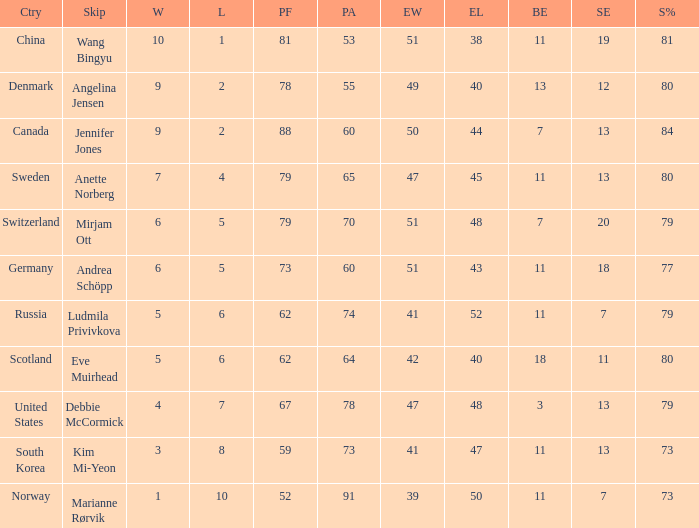What is Norway's least ends lost? 50.0. Help me parse the entirety of this table. {'header': ['Ctry', 'Skip', 'W', 'L', 'PF', 'PA', 'EW', 'EL', 'BE', 'SE', 'S%'], 'rows': [['China', 'Wang Bingyu', '10', '1', '81', '53', '51', '38', '11', '19', '81'], ['Denmark', 'Angelina Jensen', '9', '2', '78', '55', '49', '40', '13', '12', '80'], ['Canada', 'Jennifer Jones', '9', '2', '88', '60', '50', '44', '7', '13', '84'], ['Sweden', 'Anette Norberg', '7', '4', '79', '65', '47', '45', '11', '13', '80'], ['Switzerland', 'Mirjam Ott', '6', '5', '79', '70', '51', '48', '7', '20', '79'], ['Germany', 'Andrea Schöpp', '6', '5', '73', '60', '51', '43', '11', '18', '77'], ['Russia', 'Ludmila Privivkova', '5', '6', '62', '74', '41', '52', '11', '7', '79'], ['Scotland', 'Eve Muirhead', '5', '6', '62', '64', '42', '40', '18', '11', '80'], ['United States', 'Debbie McCormick', '4', '7', '67', '78', '47', '48', '3', '13', '79'], ['South Korea', 'Kim Mi-Yeon', '3', '8', '59', '73', '41', '47', '11', '13', '73'], ['Norway', 'Marianne Rørvik', '1', '10', '52', '91', '39', '50', '11', '7', '73']]} 